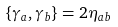Convert formula to latex. <formula><loc_0><loc_0><loc_500><loc_500>\{ \gamma _ { a } , \gamma _ { b } \} = 2 \eta _ { a b }</formula> 